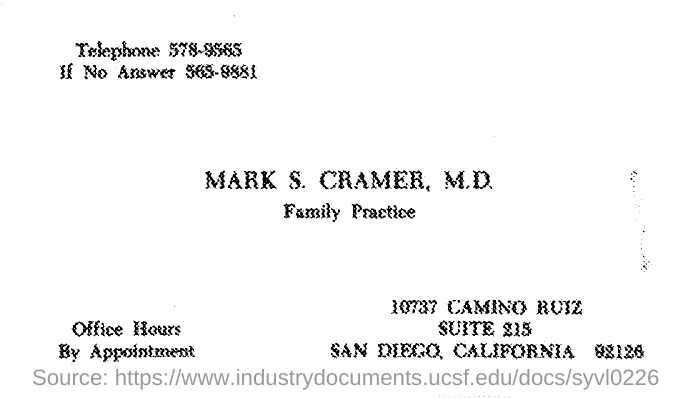What is the Telephone # (no) given?
Give a very brief answer. 578-9565. Who is the M.D. of office?
Make the answer very short. MARK S. CRAMER. 